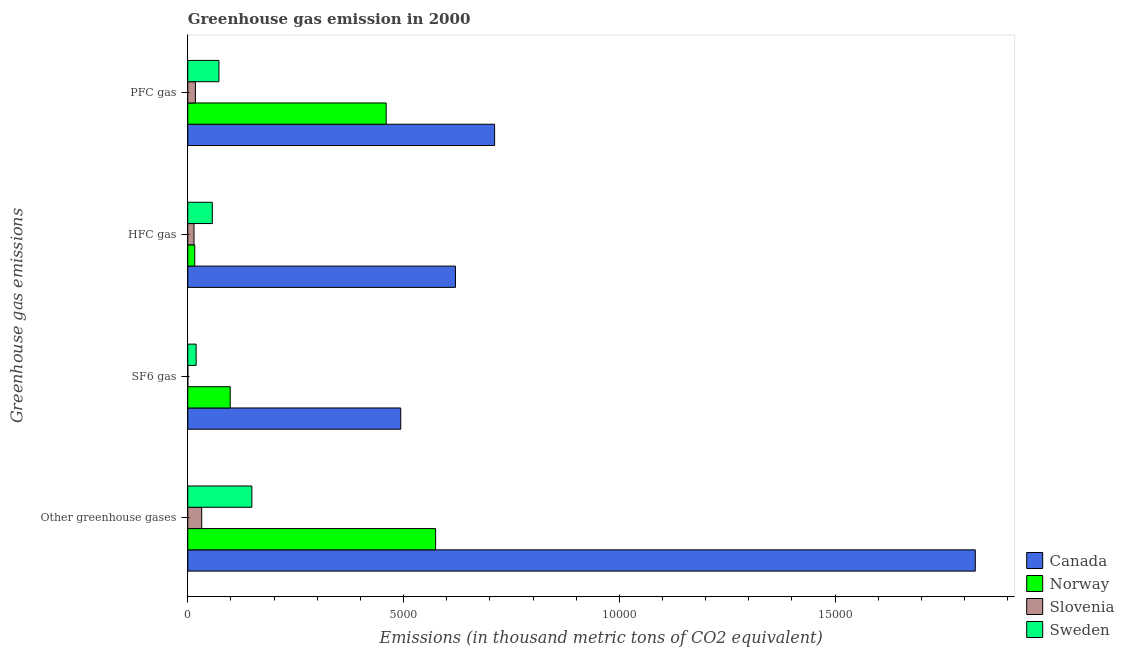Are the number of bars on each tick of the Y-axis equal?
Your response must be concise. Yes. How many bars are there on the 1st tick from the bottom?
Ensure brevity in your answer.  4. What is the label of the 4th group of bars from the top?
Make the answer very short. Other greenhouse gases. What is the emission of pfc gas in Slovenia?
Offer a terse response. 177.2. Across all countries, what is the maximum emission of pfc gas?
Make the answer very short. 7109.9. Across all countries, what is the minimum emission of hfc gas?
Offer a very short reply. 144.1. In which country was the emission of pfc gas maximum?
Your response must be concise. Canada. In which country was the emission of sf6 gas minimum?
Provide a short and direct response. Slovenia. What is the total emission of hfc gas in the graph?
Give a very brief answer. 7078. What is the difference between the emission of pfc gas in Slovenia and that in Norway?
Provide a succinct answer. -4420.1. What is the difference between the emission of hfc gas in Norway and the emission of pfc gas in Slovenia?
Provide a short and direct response. -14.9. What is the average emission of pfc gas per country?
Keep it short and to the point. 3151.73. What is the difference between the emission of hfc gas and emission of sf6 gas in Canada?
Your response must be concise. 1267.7. What is the ratio of the emission of greenhouse gases in Sweden to that in Norway?
Offer a terse response. 0.26. Is the emission of greenhouse gases in Norway less than that in Sweden?
Offer a terse response. No. What is the difference between the highest and the second highest emission of greenhouse gases?
Your response must be concise. 1.25e+04. What is the difference between the highest and the lowest emission of hfc gas?
Your answer should be very brief. 6058.7. In how many countries, is the emission of hfc gas greater than the average emission of hfc gas taken over all countries?
Provide a succinct answer. 1. Is the sum of the emission of hfc gas in Norway and Sweden greater than the maximum emission of greenhouse gases across all countries?
Provide a short and direct response. No. Is it the case that in every country, the sum of the emission of pfc gas and emission of greenhouse gases is greater than the sum of emission of hfc gas and emission of sf6 gas?
Your response must be concise. No. Are the values on the major ticks of X-axis written in scientific E-notation?
Offer a terse response. No. How many legend labels are there?
Your response must be concise. 4. How are the legend labels stacked?
Keep it short and to the point. Vertical. What is the title of the graph?
Your answer should be very brief. Greenhouse gas emission in 2000. What is the label or title of the X-axis?
Your answer should be very brief. Emissions (in thousand metric tons of CO2 equivalent). What is the label or title of the Y-axis?
Your answer should be compact. Greenhouse gas emissions. What is the Emissions (in thousand metric tons of CO2 equivalent) in Canada in Other greenhouse gases?
Give a very brief answer. 1.82e+04. What is the Emissions (in thousand metric tons of CO2 equivalent) of Norway in Other greenhouse gases?
Offer a very short reply. 5742.8. What is the Emissions (in thousand metric tons of CO2 equivalent) in Slovenia in Other greenhouse gases?
Your answer should be compact. 323.3. What is the Emissions (in thousand metric tons of CO2 equivalent) in Sweden in Other greenhouse gases?
Ensure brevity in your answer.  1485.3. What is the Emissions (in thousand metric tons of CO2 equivalent) in Canada in SF6 gas?
Your answer should be very brief. 4935.1. What is the Emissions (in thousand metric tons of CO2 equivalent) in Norway in SF6 gas?
Offer a terse response. 983.2. What is the Emissions (in thousand metric tons of CO2 equivalent) in Slovenia in SF6 gas?
Offer a terse response. 2. What is the Emissions (in thousand metric tons of CO2 equivalent) of Sweden in SF6 gas?
Your response must be concise. 194. What is the Emissions (in thousand metric tons of CO2 equivalent) of Canada in HFC gas?
Your answer should be very brief. 6202.8. What is the Emissions (in thousand metric tons of CO2 equivalent) in Norway in HFC gas?
Offer a very short reply. 162.3. What is the Emissions (in thousand metric tons of CO2 equivalent) in Slovenia in HFC gas?
Ensure brevity in your answer.  144.1. What is the Emissions (in thousand metric tons of CO2 equivalent) in Sweden in HFC gas?
Make the answer very short. 568.8. What is the Emissions (in thousand metric tons of CO2 equivalent) in Canada in PFC gas?
Make the answer very short. 7109.9. What is the Emissions (in thousand metric tons of CO2 equivalent) in Norway in PFC gas?
Ensure brevity in your answer.  4597.3. What is the Emissions (in thousand metric tons of CO2 equivalent) in Slovenia in PFC gas?
Your answer should be very brief. 177.2. What is the Emissions (in thousand metric tons of CO2 equivalent) in Sweden in PFC gas?
Offer a very short reply. 722.5. Across all Greenhouse gas emissions, what is the maximum Emissions (in thousand metric tons of CO2 equivalent) of Canada?
Your answer should be compact. 1.82e+04. Across all Greenhouse gas emissions, what is the maximum Emissions (in thousand metric tons of CO2 equivalent) in Norway?
Your answer should be compact. 5742.8. Across all Greenhouse gas emissions, what is the maximum Emissions (in thousand metric tons of CO2 equivalent) in Slovenia?
Your response must be concise. 323.3. Across all Greenhouse gas emissions, what is the maximum Emissions (in thousand metric tons of CO2 equivalent) in Sweden?
Make the answer very short. 1485.3. Across all Greenhouse gas emissions, what is the minimum Emissions (in thousand metric tons of CO2 equivalent) of Canada?
Provide a succinct answer. 4935.1. Across all Greenhouse gas emissions, what is the minimum Emissions (in thousand metric tons of CO2 equivalent) in Norway?
Offer a very short reply. 162.3. Across all Greenhouse gas emissions, what is the minimum Emissions (in thousand metric tons of CO2 equivalent) in Slovenia?
Provide a succinct answer. 2. Across all Greenhouse gas emissions, what is the minimum Emissions (in thousand metric tons of CO2 equivalent) of Sweden?
Give a very brief answer. 194. What is the total Emissions (in thousand metric tons of CO2 equivalent) in Canada in the graph?
Provide a short and direct response. 3.65e+04. What is the total Emissions (in thousand metric tons of CO2 equivalent) in Norway in the graph?
Ensure brevity in your answer.  1.15e+04. What is the total Emissions (in thousand metric tons of CO2 equivalent) in Slovenia in the graph?
Your response must be concise. 646.6. What is the total Emissions (in thousand metric tons of CO2 equivalent) of Sweden in the graph?
Make the answer very short. 2970.6. What is the difference between the Emissions (in thousand metric tons of CO2 equivalent) of Canada in Other greenhouse gases and that in SF6 gas?
Provide a short and direct response. 1.33e+04. What is the difference between the Emissions (in thousand metric tons of CO2 equivalent) of Norway in Other greenhouse gases and that in SF6 gas?
Give a very brief answer. 4759.6. What is the difference between the Emissions (in thousand metric tons of CO2 equivalent) of Slovenia in Other greenhouse gases and that in SF6 gas?
Your response must be concise. 321.3. What is the difference between the Emissions (in thousand metric tons of CO2 equivalent) of Sweden in Other greenhouse gases and that in SF6 gas?
Keep it short and to the point. 1291.3. What is the difference between the Emissions (in thousand metric tons of CO2 equivalent) in Canada in Other greenhouse gases and that in HFC gas?
Make the answer very short. 1.20e+04. What is the difference between the Emissions (in thousand metric tons of CO2 equivalent) in Norway in Other greenhouse gases and that in HFC gas?
Provide a succinct answer. 5580.5. What is the difference between the Emissions (in thousand metric tons of CO2 equivalent) of Slovenia in Other greenhouse gases and that in HFC gas?
Offer a very short reply. 179.2. What is the difference between the Emissions (in thousand metric tons of CO2 equivalent) in Sweden in Other greenhouse gases and that in HFC gas?
Give a very brief answer. 916.5. What is the difference between the Emissions (in thousand metric tons of CO2 equivalent) of Canada in Other greenhouse gases and that in PFC gas?
Your response must be concise. 1.11e+04. What is the difference between the Emissions (in thousand metric tons of CO2 equivalent) in Norway in Other greenhouse gases and that in PFC gas?
Provide a succinct answer. 1145.5. What is the difference between the Emissions (in thousand metric tons of CO2 equivalent) in Slovenia in Other greenhouse gases and that in PFC gas?
Provide a succinct answer. 146.1. What is the difference between the Emissions (in thousand metric tons of CO2 equivalent) of Sweden in Other greenhouse gases and that in PFC gas?
Keep it short and to the point. 762.8. What is the difference between the Emissions (in thousand metric tons of CO2 equivalent) in Canada in SF6 gas and that in HFC gas?
Offer a terse response. -1267.7. What is the difference between the Emissions (in thousand metric tons of CO2 equivalent) in Norway in SF6 gas and that in HFC gas?
Provide a succinct answer. 820.9. What is the difference between the Emissions (in thousand metric tons of CO2 equivalent) of Slovenia in SF6 gas and that in HFC gas?
Give a very brief answer. -142.1. What is the difference between the Emissions (in thousand metric tons of CO2 equivalent) in Sweden in SF6 gas and that in HFC gas?
Make the answer very short. -374.8. What is the difference between the Emissions (in thousand metric tons of CO2 equivalent) of Canada in SF6 gas and that in PFC gas?
Keep it short and to the point. -2174.8. What is the difference between the Emissions (in thousand metric tons of CO2 equivalent) in Norway in SF6 gas and that in PFC gas?
Offer a very short reply. -3614.1. What is the difference between the Emissions (in thousand metric tons of CO2 equivalent) of Slovenia in SF6 gas and that in PFC gas?
Offer a very short reply. -175.2. What is the difference between the Emissions (in thousand metric tons of CO2 equivalent) in Sweden in SF6 gas and that in PFC gas?
Provide a succinct answer. -528.5. What is the difference between the Emissions (in thousand metric tons of CO2 equivalent) of Canada in HFC gas and that in PFC gas?
Make the answer very short. -907.1. What is the difference between the Emissions (in thousand metric tons of CO2 equivalent) of Norway in HFC gas and that in PFC gas?
Provide a short and direct response. -4435. What is the difference between the Emissions (in thousand metric tons of CO2 equivalent) in Slovenia in HFC gas and that in PFC gas?
Provide a short and direct response. -33.1. What is the difference between the Emissions (in thousand metric tons of CO2 equivalent) in Sweden in HFC gas and that in PFC gas?
Your answer should be very brief. -153.7. What is the difference between the Emissions (in thousand metric tons of CO2 equivalent) in Canada in Other greenhouse gases and the Emissions (in thousand metric tons of CO2 equivalent) in Norway in SF6 gas?
Provide a succinct answer. 1.73e+04. What is the difference between the Emissions (in thousand metric tons of CO2 equivalent) in Canada in Other greenhouse gases and the Emissions (in thousand metric tons of CO2 equivalent) in Slovenia in SF6 gas?
Your response must be concise. 1.82e+04. What is the difference between the Emissions (in thousand metric tons of CO2 equivalent) in Canada in Other greenhouse gases and the Emissions (in thousand metric tons of CO2 equivalent) in Sweden in SF6 gas?
Provide a succinct answer. 1.81e+04. What is the difference between the Emissions (in thousand metric tons of CO2 equivalent) of Norway in Other greenhouse gases and the Emissions (in thousand metric tons of CO2 equivalent) of Slovenia in SF6 gas?
Offer a very short reply. 5740.8. What is the difference between the Emissions (in thousand metric tons of CO2 equivalent) in Norway in Other greenhouse gases and the Emissions (in thousand metric tons of CO2 equivalent) in Sweden in SF6 gas?
Your answer should be compact. 5548.8. What is the difference between the Emissions (in thousand metric tons of CO2 equivalent) in Slovenia in Other greenhouse gases and the Emissions (in thousand metric tons of CO2 equivalent) in Sweden in SF6 gas?
Offer a very short reply. 129.3. What is the difference between the Emissions (in thousand metric tons of CO2 equivalent) in Canada in Other greenhouse gases and the Emissions (in thousand metric tons of CO2 equivalent) in Norway in HFC gas?
Provide a succinct answer. 1.81e+04. What is the difference between the Emissions (in thousand metric tons of CO2 equivalent) in Canada in Other greenhouse gases and the Emissions (in thousand metric tons of CO2 equivalent) in Slovenia in HFC gas?
Make the answer very short. 1.81e+04. What is the difference between the Emissions (in thousand metric tons of CO2 equivalent) of Canada in Other greenhouse gases and the Emissions (in thousand metric tons of CO2 equivalent) of Sweden in HFC gas?
Provide a short and direct response. 1.77e+04. What is the difference between the Emissions (in thousand metric tons of CO2 equivalent) in Norway in Other greenhouse gases and the Emissions (in thousand metric tons of CO2 equivalent) in Slovenia in HFC gas?
Your answer should be compact. 5598.7. What is the difference between the Emissions (in thousand metric tons of CO2 equivalent) in Norway in Other greenhouse gases and the Emissions (in thousand metric tons of CO2 equivalent) in Sweden in HFC gas?
Make the answer very short. 5174. What is the difference between the Emissions (in thousand metric tons of CO2 equivalent) of Slovenia in Other greenhouse gases and the Emissions (in thousand metric tons of CO2 equivalent) of Sweden in HFC gas?
Provide a succinct answer. -245.5. What is the difference between the Emissions (in thousand metric tons of CO2 equivalent) in Canada in Other greenhouse gases and the Emissions (in thousand metric tons of CO2 equivalent) in Norway in PFC gas?
Make the answer very short. 1.37e+04. What is the difference between the Emissions (in thousand metric tons of CO2 equivalent) of Canada in Other greenhouse gases and the Emissions (in thousand metric tons of CO2 equivalent) of Slovenia in PFC gas?
Offer a terse response. 1.81e+04. What is the difference between the Emissions (in thousand metric tons of CO2 equivalent) of Canada in Other greenhouse gases and the Emissions (in thousand metric tons of CO2 equivalent) of Sweden in PFC gas?
Provide a succinct answer. 1.75e+04. What is the difference between the Emissions (in thousand metric tons of CO2 equivalent) of Norway in Other greenhouse gases and the Emissions (in thousand metric tons of CO2 equivalent) of Slovenia in PFC gas?
Your response must be concise. 5565.6. What is the difference between the Emissions (in thousand metric tons of CO2 equivalent) in Norway in Other greenhouse gases and the Emissions (in thousand metric tons of CO2 equivalent) in Sweden in PFC gas?
Your answer should be very brief. 5020.3. What is the difference between the Emissions (in thousand metric tons of CO2 equivalent) of Slovenia in Other greenhouse gases and the Emissions (in thousand metric tons of CO2 equivalent) of Sweden in PFC gas?
Provide a succinct answer. -399.2. What is the difference between the Emissions (in thousand metric tons of CO2 equivalent) in Canada in SF6 gas and the Emissions (in thousand metric tons of CO2 equivalent) in Norway in HFC gas?
Offer a very short reply. 4772.8. What is the difference between the Emissions (in thousand metric tons of CO2 equivalent) of Canada in SF6 gas and the Emissions (in thousand metric tons of CO2 equivalent) of Slovenia in HFC gas?
Make the answer very short. 4791. What is the difference between the Emissions (in thousand metric tons of CO2 equivalent) of Canada in SF6 gas and the Emissions (in thousand metric tons of CO2 equivalent) of Sweden in HFC gas?
Keep it short and to the point. 4366.3. What is the difference between the Emissions (in thousand metric tons of CO2 equivalent) in Norway in SF6 gas and the Emissions (in thousand metric tons of CO2 equivalent) in Slovenia in HFC gas?
Provide a succinct answer. 839.1. What is the difference between the Emissions (in thousand metric tons of CO2 equivalent) of Norway in SF6 gas and the Emissions (in thousand metric tons of CO2 equivalent) of Sweden in HFC gas?
Give a very brief answer. 414.4. What is the difference between the Emissions (in thousand metric tons of CO2 equivalent) of Slovenia in SF6 gas and the Emissions (in thousand metric tons of CO2 equivalent) of Sweden in HFC gas?
Ensure brevity in your answer.  -566.8. What is the difference between the Emissions (in thousand metric tons of CO2 equivalent) of Canada in SF6 gas and the Emissions (in thousand metric tons of CO2 equivalent) of Norway in PFC gas?
Offer a very short reply. 337.8. What is the difference between the Emissions (in thousand metric tons of CO2 equivalent) of Canada in SF6 gas and the Emissions (in thousand metric tons of CO2 equivalent) of Slovenia in PFC gas?
Provide a succinct answer. 4757.9. What is the difference between the Emissions (in thousand metric tons of CO2 equivalent) of Canada in SF6 gas and the Emissions (in thousand metric tons of CO2 equivalent) of Sweden in PFC gas?
Your response must be concise. 4212.6. What is the difference between the Emissions (in thousand metric tons of CO2 equivalent) in Norway in SF6 gas and the Emissions (in thousand metric tons of CO2 equivalent) in Slovenia in PFC gas?
Make the answer very short. 806. What is the difference between the Emissions (in thousand metric tons of CO2 equivalent) in Norway in SF6 gas and the Emissions (in thousand metric tons of CO2 equivalent) in Sweden in PFC gas?
Your answer should be very brief. 260.7. What is the difference between the Emissions (in thousand metric tons of CO2 equivalent) of Slovenia in SF6 gas and the Emissions (in thousand metric tons of CO2 equivalent) of Sweden in PFC gas?
Keep it short and to the point. -720.5. What is the difference between the Emissions (in thousand metric tons of CO2 equivalent) in Canada in HFC gas and the Emissions (in thousand metric tons of CO2 equivalent) in Norway in PFC gas?
Give a very brief answer. 1605.5. What is the difference between the Emissions (in thousand metric tons of CO2 equivalent) of Canada in HFC gas and the Emissions (in thousand metric tons of CO2 equivalent) of Slovenia in PFC gas?
Give a very brief answer. 6025.6. What is the difference between the Emissions (in thousand metric tons of CO2 equivalent) in Canada in HFC gas and the Emissions (in thousand metric tons of CO2 equivalent) in Sweden in PFC gas?
Offer a terse response. 5480.3. What is the difference between the Emissions (in thousand metric tons of CO2 equivalent) in Norway in HFC gas and the Emissions (in thousand metric tons of CO2 equivalent) in Slovenia in PFC gas?
Your answer should be very brief. -14.9. What is the difference between the Emissions (in thousand metric tons of CO2 equivalent) of Norway in HFC gas and the Emissions (in thousand metric tons of CO2 equivalent) of Sweden in PFC gas?
Your answer should be compact. -560.2. What is the difference between the Emissions (in thousand metric tons of CO2 equivalent) in Slovenia in HFC gas and the Emissions (in thousand metric tons of CO2 equivalent) in Sweden in PFC gas?
Offer a very short reply. -578.4. What is the average Emissions (in thousand metric tons of CO2 equivalent) of Canada per Greenhouse gas emissions?
Ensure brevity in your answer.  9123.9. What is the average Emissions (in thousand metric tons of CO2 equivalent) of Norway per Greenhouse gas emissions?
Your answer should be compact. 2871.4. What is the average Emissions (in thousand metric tons of CO2 equivalent) of Slovenia per Greenhouse gas emissions?
Provide a succinct answer. 161.65. What is the average Emissions (in thousand metric tons of CO2 equivalent) of Sweden per Greenhouse gas emissions?
Keep it short and to the point. 742.65. What is the difference between the Emissions (in thousand metric tons of CO2 equivalent) in Canada and Emissions (in thousand metric tons of CO2 equivalent) in Norway in Other greenhouse gases?
Provide a short and direct response. 1.25e+04. What is the difference between the Emissions (in thousand metric tons of CO2 equivalent) in Canada and Emissions (in thousand metric tons of CO2 equivalent) in Slovenia in Other greenhouse gases?
Keep it short and to the point. 1.79e+04. What is the difference between the Emissions (in thousand metric tons of CO2 equivalent) in Canada and Emissions (in thousand metric tons of CO2 equivalent) in Sweden in Other greenhouse gases?
Offer a terse response. 1.68e+04. What is the difference between the Emissions (in thousand metric tons of CO2 equivalent) in Norway and Emissions (in thousand metric tons of CO2 equivalent) in Slovenia in Other greenhouse gases?
Your answer should be compact. 5419.5. What is the difference between the Emissions (in thousand metric tons of CO2 equivalent) of Norway and Emissions (in thousand metric tons of CO2 equivalent) of Sweden in Other greenhouse gases?
Ensure brevity in your answer.  4257.5. What is the difference between the Emissions (in thousand metric tons of CO2 equivalent) of Slovenia and Emissions (in thousand metric tons of CO2 equivalent) of Sweden in Other greenhouse gases?
Provide a short and direct response. -1162. What is the difference between the Emissions (in thousand metric tons of CO2 equivalent) in Canada and Emissions (in thousand metric tons of CO2 equivalent) in Norway in SF6 gas?
Provide a short and direct response. 3951.9. What is the difference between the Emissions (in thousand metric tons of CO2 equivalent) of Canada and Emissions (in thousand metric tons of CO2 equivalent) of Slovenia in SF6 gas?
Make the answer very short. 4933.1. What is the difference between the Emissions (in thousand metric tons of CO2 equivalent) in Canada and Emissions (in thousand metric tons of CO2 equivalent) in Sweden in SF6 gas?
Your response must be concise. 4741.1. What is the difference between the Emissions (in thousand metric tons of CO2 equivalent) in Norway and Emissions (in thousand metric tons of CO2 equivalent) in Slovenia in SF6 gas?
Offer a very short reply. 981.2. What is the difference between the Emissions (in thousand metric tons of CO2 equivalent) of Norway and Emissions (in thousand metric tons of CO2 equivalent) of Sweden in SF6 gas?
Offer a very short reply. 789.2. What is the difference between the Emissions (in thousand metric tons of CO2 equivalent) of Slovenia and Emissions (in thousand metric tons of CO2 equivalent) of Sweden in SF6 gas?
Offer a very short reply. -192. What is the difference between the Emissions (in thousand metric tons of CO2 equivalent) in Canada and Emissions (in thousand metric tons of CO2 equivalent) in Norway in HFC gas?
Offer a very short reply. 6040.5. What is the difference between the Emissions (in thousand metric tons of CO2 equivalent) of Canada and Emissions (in thousand metric tons of CO2 equivalent) of Slovenia in HFC gas?
Keep it short and to the point. 6058.7. What is the difference between the Emissions (in thousand metric tons of CO2 equivalent) of Canada and Emissions (in thousand metric tons of CO2 equivalent) of Sweden in HFC gas?
Your answer should be compact. 5634. What is the difference between the Emissions (in thousand metric tons of CO2 equivalent) of Norway and Emissions (in thousand metric tons of CO2 equivalent) of Sweden in HFC gas?
Offer a very short reply. -406.5. What is the difference between the Emissions (in thousand metric tons of CO2 equivalent) in Slovenia and Emissions (in thousand metric tons of CO2 equivalent) in Sweden in HFC gas?
Your answer should be very brief. -424.7. What is the difference between the Emissions (in thousand metric tons of CO2 equivalent) of Canada and Emissions (in thousand metric tons of CO2 equivalent) of Norway in PFC gas?
Offer a very short reply. 2512.6. What is the difference between the Emissions (in thousand metric tons of CO2 equivalent) of Canada and Emissions (in thousand metric tons of CO2 equivalent) of Slovenia in PFC gas?
Offer a very short reply. 6932.7. What is the difference between the Emissions (in thousand metric tons of CO2 equivalent) in Canada and Emissions (in thousand metric tons of CO2 equivalent) in Sweden in PFC gas?
Provide a succinct answer. 6387.4. What is the difference between the Emissions (in thousand metric tons of CO2 equivalent) of Norway and Emissions (in thousand metric tons of CO2 equivalent) of Slovenia in PFC gas?
Your answer should be compact. 4420.1. What is the difference between the Emissions (in thousand metric tons of CO2 equivalent) in Norway and Emissions (in thousand metric tons of CO2 equivalent) in Sweden in PFC gas?
Ensure brevity in your answer.  3874.8. What is the difference between the Emissions (in thousand metric tons of CO2 equivalent) in Slovenia and Emissions (in thousand metric tons of CO2 equivalent) in Sweden in PFC gas?
Provide a short and direct response. -545.3. What is the ratio of the Emissions (in thousand metric tons of CO2 equivalent) of Canada in Other greenhouse gases to that in SF6 gas?
Offer a terse response. 3.7. What is the ratio of the Emissions (in thousand metric tons of CO2 equivalent) in Norway in Other greenhouse gases to that in SF6 gas?
Offer a very short reply. 5.84. What is the ratio of the Emissions (in thousand metric tons of CO2 equivalent) of Slovenia in Other greenhouse gases to that in SF6 gas?
Your answer should be very brief. 161.65. What is the ratio of the Emissions (in thousand metric tons of CO2 equivalent) in Sweden in Other greenhouse gases to that in SF6 gas?
Your answer should be very brief. 7.66. What is the ratio of the Emissions (in thousand metric tons of CO2 equivalent) of Canada in Other greenhouse gases to that in HFC gas?
Your answer should be compact. 2.94. What is the ratio of the Emissions (in thousand metric tons of CO2 equivalent) in Norway in Other greenhouse gases to that in HFC gas?
Your answer should be very brief. 35.38. What is the ratio of the Emissions (in thousand metric tons of CO2 equivalent) of Slovenia in Other greenhouse gases to that in HFC gas?
Provide a short and direct response. 2.24. What is the ratio of the Emissions (in thousand metric tons of CO2 equivalent) of Sweden in Other greenhouse gases to that in HFC gas?
Provide a short and direct response. 2.61. What is the ratio of the Emissions (in thousand metric tons of CO2 equivalent) in Canada in Other greenhouse gases to that in PFC gas?
Make the answer very short. 2.57. What is the ratio of the Emissions (in thousand metric tons of CO2 equivalent) in Norway in Other greenhouse gases to that in PFC gas?
Provide a short and direct response. 1.25. What is the ratio of the Emissions (in thousand metric tons of CO2 equivalent) of Slovenia in Other greenhouse gases to that in PFC gas?
Offer a terse response. 1.82. What is the ratio of the Emissions (in thousand metric tons of CO2 equivalent) of Sweden in Other greenhouse gases to that in PFC gas?
Provide a short and direct response. 2.06. What is the ratio of the Emissions (in thousand metric tons of CO2 equivalent) in Canada in SF6 gas to that in HFC gas?
Keep it short and to the point. 0.8. What is the ratio of the Emissions (in thousand metric tons of CO2 equivalent) in Norway in SF6 gas to that in HFC gas?
Offer a terse response. 6.06. What is the ratio of the Emissions (in thousand metric tons of CO2 equivalent) in Slovenia in SF6 gas to that in HFC gas?
Provide a succinct answer. 0.01. What is the ratio of the Emissions (in thousand metric tons of CO2 equivalent) of Sweden in SF6 gas to that in HFC gas?
Offer a very short reply. 0.34. What is the ratio of the Emissions (in thousand metric tons of CO2 equivalent) of Canada in SF6 gas to that in PFC gas?
Offer a very short reply. 0.69. What is the ratio of the Emissions (in thousand metric tons of CO2 equivalent) of Norway in SF6 gas to that in PFC gas?
Your answer should be compact. 0.21. What is the ratio of the Emissions (in thousand metric tons of CO2 equivalent) of Slovenia in SF6 gas to that in PFC gas?
Give a very brief answer. 0.01. What is the ratio of the Emissions (in thousand metric tons of CO2 equivalent) of Sweden in SF6 gas to that in PFC gas?
Offer a terse response. 0.27. What is the ratio of the Emissions (in thousand metric tons of CO2 equivalent) of Canada in HFC gas to that in PFC gas?
Offer a terse response. 0.87. What is the ratio of the Emissions (in thousand metric tons of CO2 equivalent) of Norway in HFC gas to that in PFC gas?
Ensure brevity in your answer.  0.04. What is the ratio of the Emissions (in thousand metric tons of CO2 equivalent) of Slovenia in HFC gas to that in PFC gas?
Your answer should be very brief. 0.81. What is the ratio of the Emissions (in thousand metric tons of CO2 equivalent) of Sweden in HFC gas to that in PFC gas?
Provide a succinct answer. 0.79. What is the difference between the highest and the second highest Emissions (in thousand metric tons of CO2 equivalent) of Canada?
Your response must be concise. 1.11e+04. What is the difference between the highest and the second highest Emissions (in thousand metric tons of CO2 equivalent) of Norway?
Make the answer very short. 1145.5. What is the difference between the highest and the second highest Emissions (in thousand metric tons of CO2 equivalent) in Slovenia?
Your response must be concise. 146.1. What is the difference between the highest and the second highest Emissions (in thousand metric tons of CO2 equivalent) of Sweden?
Provide a succinct answer. 762.8. What is the difference between the highest and the lowest Emissions (in thousand metric tons of CO2 equivalent) of Canada?
Give a very brief answer. 1.33e+04. What is the difference between the highest and the lowest Emissions (in thousand metric tons of CO2 equivalent) of Norway?
Your answer should be very brief. 5580.5. What is the difference between the highest and the lowest Emissions (in thousand metric tons of CO2 equivalent) of Slovenia?
Provide a short and direct response. 321.3. What is the difference between the highest and the lowest Emissions (in thousand metric tons of CO2 equivalent) in Sweden?
Make the answer very short. 1291.3. 